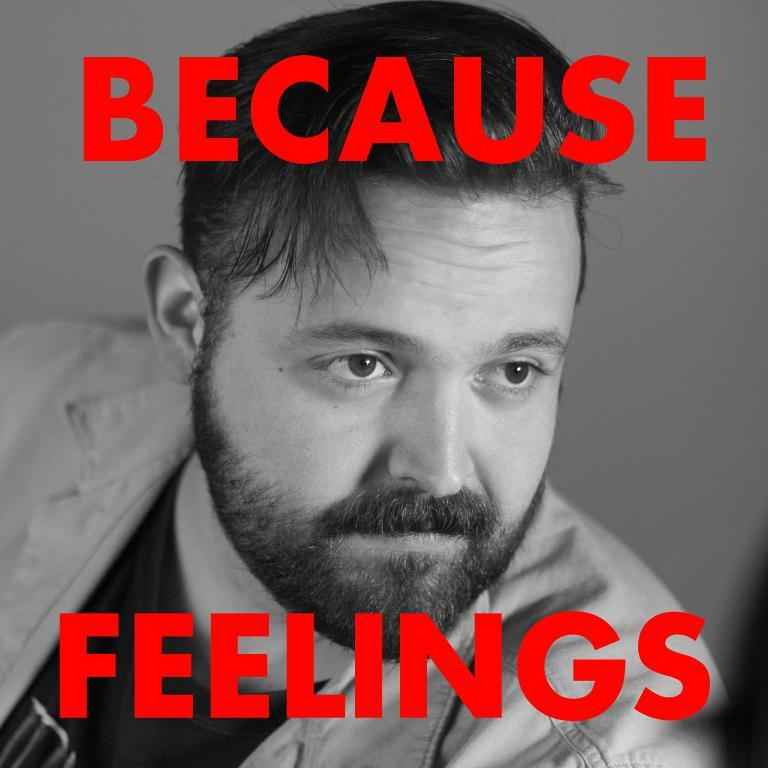Who or what is present in the image? There is a person in the image. What is the person wearing? The person is wearing a black t-shirt. What can be seen at the top and bottom of the image? There is text at the top and bottom of the image. What type of comb is the laborer using in the image? There is no laborer or comb present in the image. What reward is the person receiving for their work in the image? There is no indication of work or a reward in the image. 